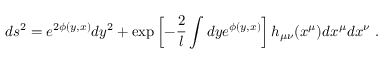Convert formula to latex. <formula><loc_0><loc_0><loc_500><loc_500>d s ^ { 2 } = e ^ { 2 \phi ( y , x ) } d y ^ { 2 } + \exp \left [ - { \frac { 2 } { l } } \int d y e ^ { \phi ( y , x ) } \right ] h _ { \mu \nu } ( x ^ { \mu } ) d x ^ { \mu } d x ^ { \nu } \ .</formula> 